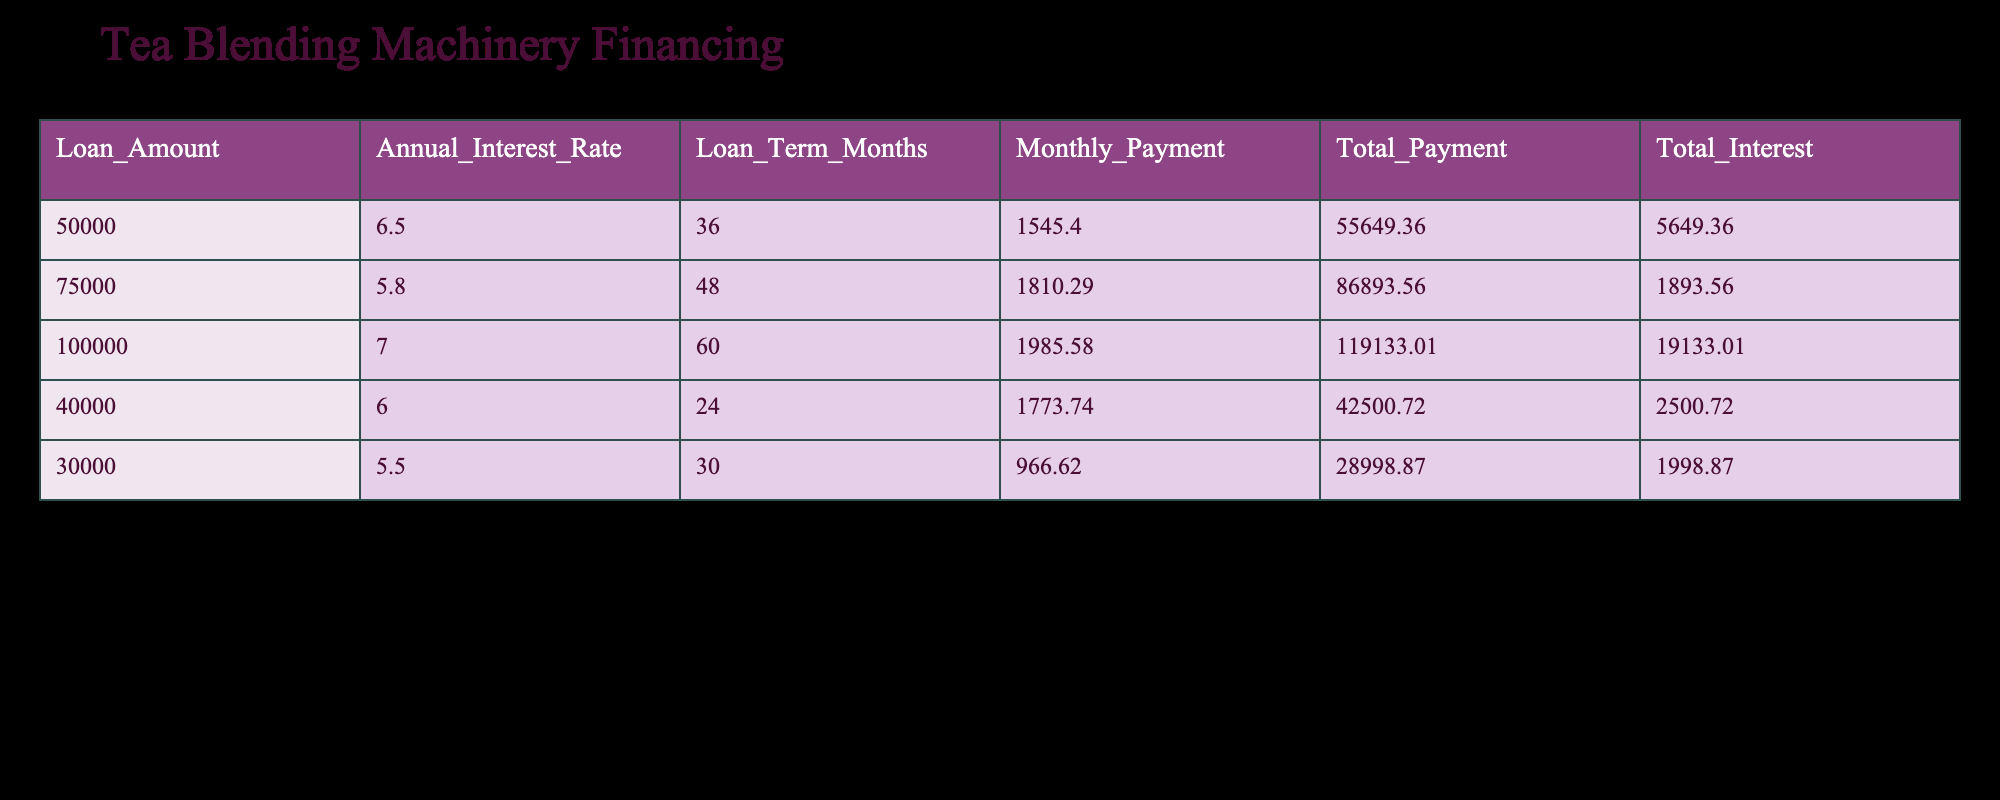What is the loan amount for the highest monthly payment? By examining the "Monthly Payment" column, we identify that the highest monthly payment is 1985.58, which corresponds to a loan amount of 100000 in the "Loan Amount" column.
Answer: 100000 What is the total interest paid for the 36-month loan? The table indicates the total interest for the 36-month loan, which is represented in the "Total Interest" column. For the loan amount of 50000, the total interest is 5649.36.
Answer: 5649.36 Is the monthly payment for the 24-month loan greater than the payment for the 30-month loan? Comparing the monthly payments in the "Monthly Payment" column, 1773.74 (24 months) is compared to 966.62 (30 months), determining that 1773.74 is greater than 966.62.
Answer: Yes How much total payment would you make for the 48-month loan? Looking at the "Total Payment" column for the 48-month loan, the value associated with the loan amount of 75000 is 86893.56.
Answer: 86893.56 What is the difference in total interest between the 60-month and 30-month loans? First, the total interest for the 60-month loan (19133.01) and the 30-month loan (1998.87) is identified. Then, subtracting gives 19133.01 - 1998.87 = 17134.14.
Answer: 17134.14 What is the average monthly payment across all loan terms? The monthly payments (1545.40, 1810.29, 1985.58, 1773.74, and 966.62) need to be summed and divided by the number of loans (5). The total is 1545.40 + 1810.29 + 1985.58 + 1773.74 + 966.62 = 10181.63, so the average is 10181.63 / 5 = 2036.33.
Answer: 2036.33 Is the annual interest rate for the 24-month loan lower than that for the 36-month loan? The annual interest rates are examined: 6.0 for the 24-month loan and 6.5 for the 36-month loan. Since 6.0 is less than 6.5, the statement is true.
Answer: Yes How many loans have a total payment over 50000? Counting the rows in the "Total Payment" column where values exceed 50000: 55649.36, 86893.56, 119133.01, and 42500.72 (which is not included) gives us 4 loans.
Answer: 4 What is the total payment for all loans combined? All total payments (55649.36, 86893.56, 119133.01, 42500.72, and 28998.87) are summed, resulting in 55649.36 + 86893.56 + 119133.01 + 42500.72 + 28998.87 = 349175.52.
Answer: 349175.52 